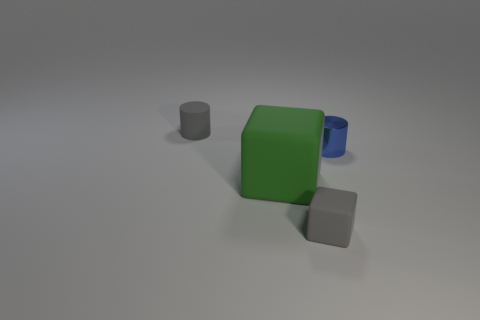Add 1 brown cylinders. How many objects exist? 5 Add 3 large rubber things. How many large rubber things are left? 4 Add 1 gray shiny cubes. How many gray shiny cubes exist? 1 Subtract 0 red spheres. How many objects are left? 4 Subtract all big blocks. Subtract all gray cylinders. How many objects are left? 2 